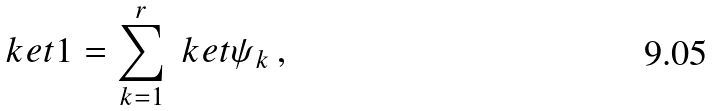<formula> <loc_0><loc_0><loc_500><loc_500>\ k e t { 1 } = \sum _ { k = 1 } ^ { r } \ k e t { \psi _ { k } } \, ,</formula> 